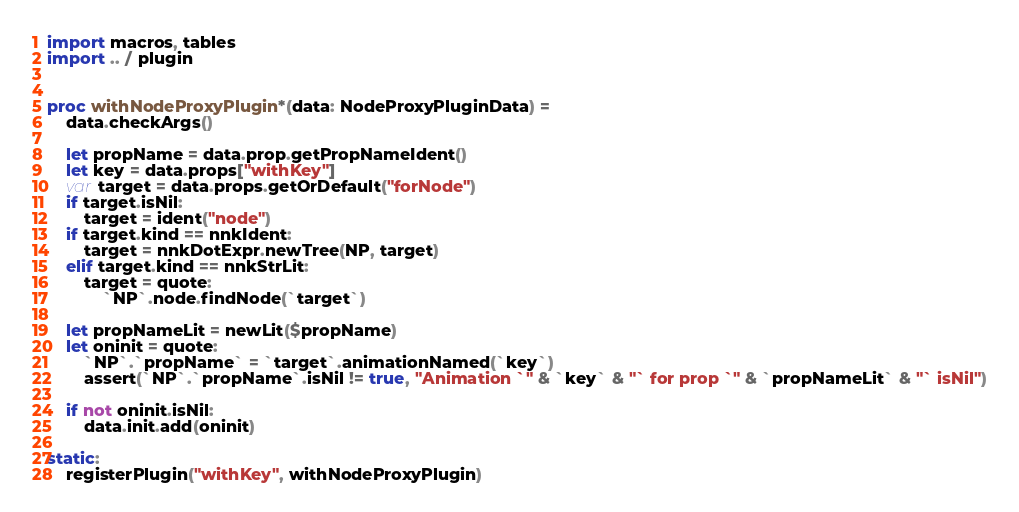Convert code to text. <code><loc_0><loc_0><loc_500><loc_500><_Nim_>import macros, tables
import .. / plugin


proc withNodeProxyPlugin*(data: NodeProxyPluginData) =
    data.checkArgs()

    let propName = data.prop.getPropNameIdent()
    let key = data.props["withKey"]
    var target = data.props.getOrDefault("forNode")
    if target.isNil:
        target = ident("node")
    if target.kind == nnkIdent:
        target = nnkDotExpr.newTree(NP, target)
    elif target.kind == nnkStrLit:
        target = quote:
            `NP`.node.findNode(`target`)
    
    let propNameLit = newLit($propName)
    let oninit = quote:
        `NP`.`propName` = `target`.animationNamed(`key`)
        assert(`NP`.`propName`.isNil != true, "Animation `" & `key` & "` for prop `" & `propNameLit` & "` isNil")
    
    if not oninit.isNil:
        data.init.add(oninit)

static:
    registerPlugin("withKey", withNodeProxyPlugin)</code> 